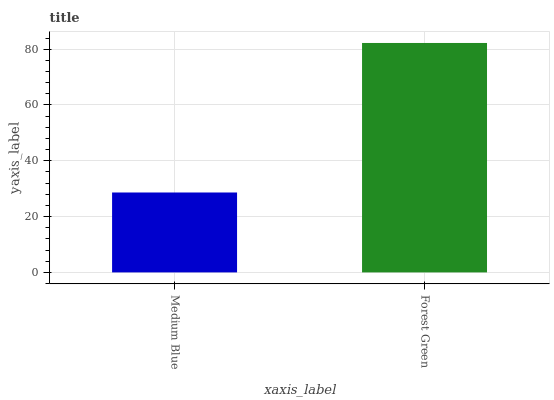Is Forest Green the minimum?
Answer yes or no. No. Is Forest Green greater than Medium Blue?
Answer yes or no. Yes. Is Medium Blue less than Forest Green?
Answer yes or no. Yes. Is Medium Blue greater than Forest Green?
Answer yes or no. No. Is Forest Green less than Medium Blue?
Answer yes or no. No. Is Forest Green the high median?
Answer yes or no. Yes. Is Medium Blue the low median?
Answer yes or no. Yes. Is Medium Blue the high median?
Answer yes or no. No. Is Forest Green the low median?
Answer yes or no. No. 